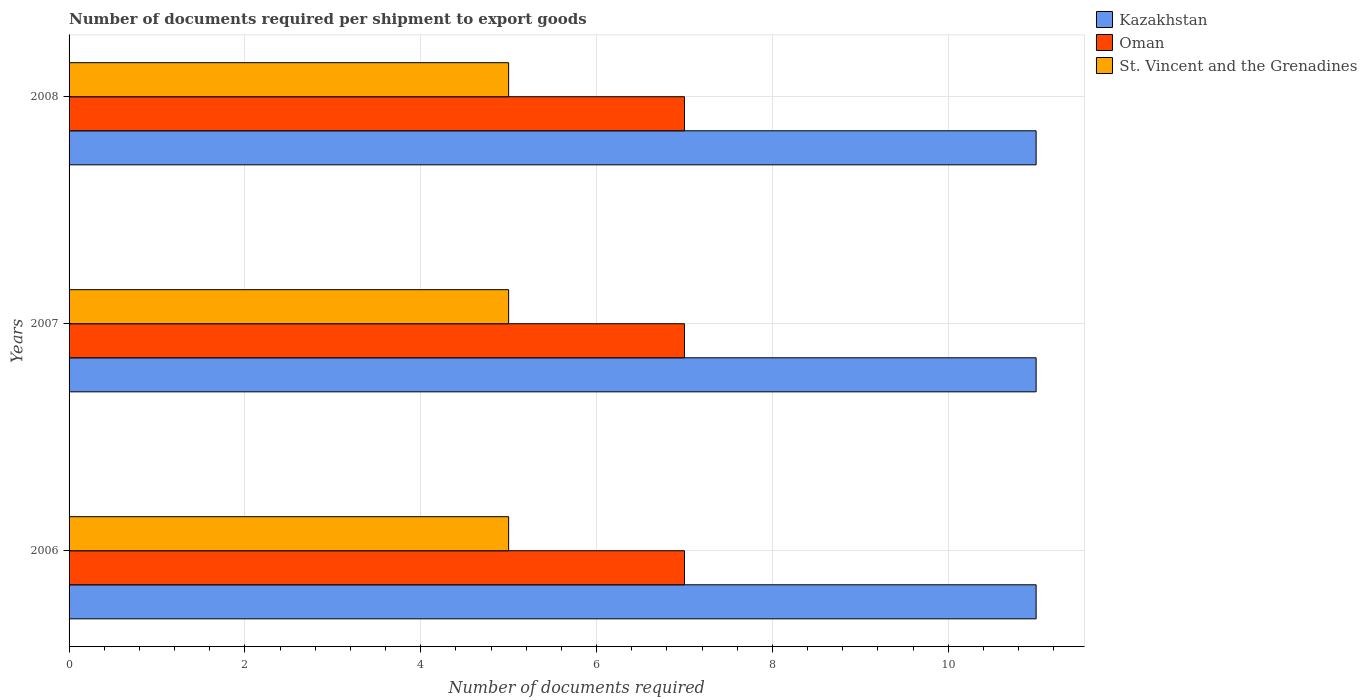How many bars are there on the 3rd tick from the top?
Your response must be concise. 3. In how many cases, is the number of bars for a given year not equal to the number of legend labels?
Give a very brief answer. 0. What is the number of documents required per shipment to export goods in St. Vincent and the Grenadines in 2007?
Make the answer very short. 5. Across all years, what is the maximum number of documents required per shipment to export goods in St. Vincent and the Grenadines?
Offer a terse response. 5. Across all years, what is the minimum number of documents required per shipment to export goods in Oman?
Your answer should be very brief. 7. What is the total number of documents required per shipment to export goods in St. Vincent and the Grenadines in the graph?
Your answer should be compact. 15. What is the difference between the number of documents required per shipment to export goods in Oman in 2007 and that in 2008?
Your answer should be compact. 0. What is the difference between the number of documents required per shipment to export goods in Kazakhstan in 2006 and the number of documents required per shipment to export goods in Oman in 2008?
Offer a very short reply. 4. What is the average number of documents required per shipment to export goods in St. Vincent and the Grenadines per year?
Make the answer very short. 5. In the year 2008, what is the difference between the number of documents required per shipment to export goods in St. Vincent and the Grenadines and number of documents required per shipment to export goods in Oman?
Your answer should be compact. -2. In how many years, is the number of documents required per shipment to export goods in Oman greater than 8.8 ?
Ensure brevity in your answer.  0. What is the ratio of the number of documents required per shipment to export goods in Kazakhstan in 2007 to that in 2008?
Your answer should be very brief. 1. Is the difference between the number of documents required per shipment to export goods in St. Vincent and the Grenadines in 2007 and 2008 greater than the difference between the number of documents required per shipment to export goods in Oman in 2007 and 2008?
Provide a succinct answer. No. In how many years, is the number of documents required per shipment to export goods in St. Vincent and the Grenadines greater than the average number of documents required per shipment to export goods in St. Vincent and the Grenadines taken over all years?
Ensure brevity in your answer.  0. What does the 2nd bar from the top in 2007 represents?
Provide a succinct answer. Oman. What does the 3rd bar from the bottom in 2007 represents?
Make the answer very short. St. Vincent and the Grenadines. What is the difference between two consecutive major ticks on the X-axis?
Provide a succinct answer. 2. Does the graph contain grids?
Offer a terse response. Yes. How many legend labels are there?
Your answer should be compact. 3. What is the title of the graph?
Make the answer very short. Number of documents required per shipment to export goods. What is the label or title of the X-axis?
Offer a very short reply. Number of documents required. What is the label or title of the Y-axis?
Ensure brevity in your answer.  Years. What is the Number of documents required in Kazakhstan in 2006?
Your answer should be very brief. 11. What is the Number of documents required of Oman in 2006?
Provide a short and direct response. 7. What is the Number of documents required of St. Vincent and the Grenadines in 2006?
Provide a succinct answer. 5. What is the Number of documents required in Oman in 2007?
Ensure brevity in your answer.  7. What is the Number of documents required in St. Vincent and the Grenadines in 2007?
Make the answer very short. 5. What is the Number of documents required of Oman in 2008?
Keep it short and to the point. 7. What is the Number of documents required in St. Vincent and the Grenadines in 2008?
Your answer should be compact. 5. Across all years, what is the maximum Number of documents required of Kazakhstan?
Keep it short and to the point. 11. Across all years, what is the maximum Number of documents required of Oman?
Offer a terse response. 7. Across all years, what is the maximum Number of documents required in St. Vincent and the Grenadines?
Make the answer very short. 5. Across all years, what is the minimum Number of documents required of Oman?
Provide a short and direct response. 7. Across all years, what is the minimum Number of documents required of St. Vincent and the Grenadines?
Your answer should be compact. 5. What is the total Number of documents required of Kazakhstan in the graph?
Your answer should be very brief. 33. What is the total Number of documents required in Oman in the graph?
Your answer should be very brief. 21. What is the total Number of documents required in St. Vincent and the Grenadines in the graph?
Provide a short and direct response. 15. What is the difference between the Number of documents required of St. Vincent and the Grenadines in 2006 and that in 2008?
Ensure brevity in your answer.  0. What is the difference between the Number of documents required in Kazakhstan in 2006 and the Number of documents required in St. Vincent and the Grenadines in 2007?
Keep it short and to the point. 6. What is the difference between the Number of documents required in Kazakhstan in 2006 and the Number of documents required in St. Vincent and the Grenadines in 2008?
Provide a succinct answer. 6. What is the difference between the Number of documents required in Oman in 2006 and the Number of documents required in St. Vincent and the Grenadines in 2008?
Provide a succinct answer. 2. What is the difference between the Number of documents required in Kazakhstan in 2007 and the Number of documents required in Oman in 2008?
Your answer should be very brief. 4. What is the difference between the Number of documents required in Kazakhstan in 2007 and the Number of documents required in St. Vincent and the Grenadines in 2008?
Give a very brief answer. 6. What is the average Number of documents required of Kazakhstan per year?
Your answer should be very brief. 11. What is the average Number of documents required in Oman per year?
Provide a short and direct response. 7. What is the average Number of documents required in St. Vincent and the Grenadines per year?
Your answer should be very brief. 5. In the year 2006, what is the difference between the Number of documents required of Kazakhstan and Number of documents required of St. Vincent and the Grenadines?
Provide a succinct answer. 6. In the year 2006, what is the difference between the Number of documents required in Oman and Number of documents required in St. Vincent and the Grenadines?
Your answer should be very brief. 2. In the year 2007, what is the difference between the Number of documents required in Kazakhstan and Number of documents required in Oman?
Offer a very short reply. 4. In the year 2007, what is the difference between the Number of documents required in Kazakhstan and Number of documents required in St. Vincent and the Grenadines?
Offer a terse response. 6. In the year 2008, what is the difference between the Number of documents required of Kazakhstan and Number of documents required of Oman?
Offer a terse response. 4. What is the ratio of the Number of documents required of St. Vincent and the Grenadines in 2006 to that in 2007?
Your answer should be very brief. 1. What is the ratio of the Number of documents required of Oman in 2006 to that in 2008?
Your answer should be very brief. 1. What is the ratio of the Number of documents required of St. Vincent and the Grenadines in 2006 to that in 2008?
Ensure brevity in your answer.  1. What is the ratio of the Number of documents required in Oman in 2007 to that in 2008?
Make the answer very short. 1. What is the difference between the highest and the second highest Number of documents required in Kazakhstan?
Give a very brief answer. 0. What is the difference between the highest and the second highest Number of documents required of St. Vincent and the Grenadines?
Give a very brief answer. 0. What is the difference between the highest and the lowest Number of documents required of St. Vincent and the Grenadines?
Provide a succinct answer. 0. 